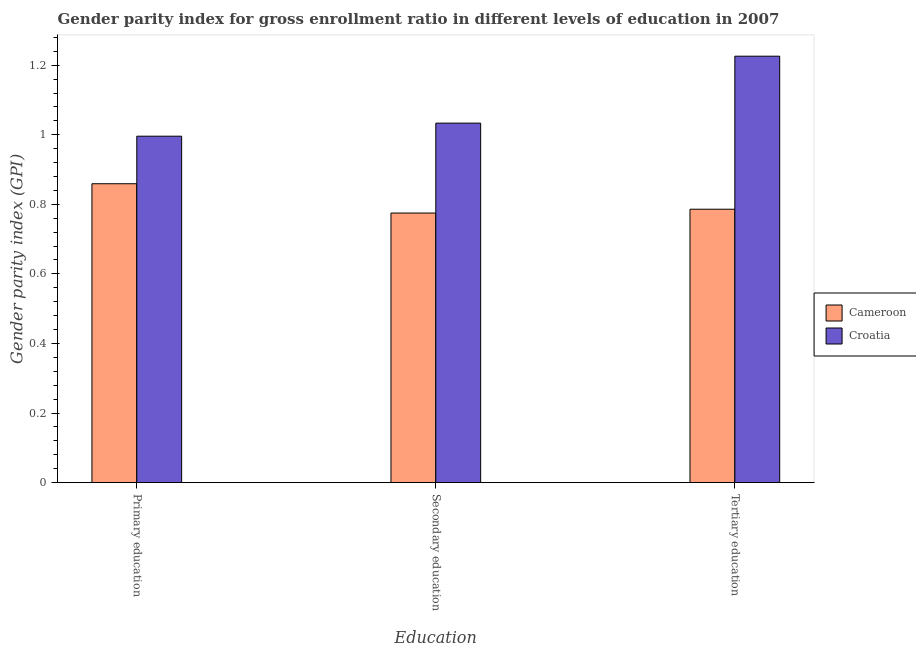How many groups of bars are there?
Provide a succinct answer. 3. Are the number of bars per tick equal to the number of legend labels?
Provide a short and direct response. Yes. What is the label of the 1st group of bars from the left?
Offer a terse response. Primary education. What is the gender parity index in secondary education in Cameroon?
Provide a succinct answer. 0.77. Across all countries, what is the maximum gender parity index in tertiary education?
Ensure brevity in your answer.  1.23. Across all countries, what is the minimum gender parity index in tertiary education?
Your response must be concise. 0.79. In which country was the gender parity index in primary education maximum?
Your answer should be compact. Croatia. In which country was the gender parity index in tertiary education minimum?
Your answer should be compact. Cameroon. What is the total gender parity index in primary education in the graph?
Your response must be concise. 1.86. What is the difference between the gender parity index in secondary education in Croatia and that in Cameroon?
Provide a succinct answer. 0.26. What is the difference between the gender parity index in tertiary education in Cameroon and the gender parity index in primary education in Croatia?
Your response must be concise. -0.21. What is the average gender parity index in secondary education per country?
Your answer should be very brief. 0.9. What is the difference between the gender parity index in primary education and gender parity index in secondary education in Cameroon?
Ensure brevity in your answer.  0.08. What is the ratio of the gender parity index in secondary education in Croatia to that in Cameroon?
Ensure brevity in your answer.  1.33. Is the gender parity index in primary education in Cameroon less than that in Croatia?
Your response must be concise. Yes. Is the difference between the gender parity index in primary education in Cameroon and Croatia greater than the difference between the gender parity index in secondary education in Cameroon and Croatia?
Your response must be concise. Yes. What is the difference between the highest and the second highest gender parity index in primary education?
Make the answer very short. 0.14. What is the difference between the highest and the lowest gender parity index in secondary education?
Your answer should be compact. 0.26. Is the sum of the gender parity index in secondary education in Croatia and Cameroon greater than the maximum gender parity index in tertiary education across all countries?
Your answer should be very brief. Yes. What does the 2nd bar from the left in Tertiary education represents?
Keep it short and to the point. Croatia. What does the 1st bar from the right in Secondary education represents?
Offer a terse response. Croatia. Is it the case that in every country, the sum of the gender parity index in primary education and gender parity index in secondary education is greater than the gender parity index in tertiary education?
Provide a short and direct response. Yes. Are all the bars in the graph horizontal?
Offer a very short reply. No. Are the values on the major ticks of Y-axis written in scientific E-notation?
Keep it short and to the point. No. Does the graph contain any zero values?
Keep it short and to the point. No. How many legend labels are there?
Offer a terse response. 2. What is the title of the graph?
Provide a short and direct response. Gender parity index for gross enrollment ratio in different levels of education in 2007. What is the label or title of the X-axis?
Provide a short and direct response. Education. What is the label or title of the Y-axis?
Ensure brevity in your answer.  Gender parity index (GPI). What is the Gender parity index (GPI) of Cameroon in Primary education?
Ensure brevity in your answer.  0.86. What is the Gender parity index (GPI) in Croatia in Primary education?
Ensure brevity in your answer.  1. What is the Gender parity index (GPI) of Cameroon in Secondary education?
Your answer should be very brief. 0.77. What is the Gender parity index (GPI) in Croatia in Secondary education?
Ensure brevity in your answer.  1.03. What is the Gender parity index (GPI) in Cameroon in Tertiary education?
Offer a terse response. 0.79. What is the Gender parity index (GPI) of Croatia in Tertiary education?
Keep it short and to the point. 1.23. Across all Education, what is the maximum Gender parity index (GPI) in Cameroon?
Your response must be concise. 0.86. Across all Education, what is the maximum Gender parity index (GPI) of Croatia?
Keep it short and to the point. 1.23. Across all Education, what is the minimum Gender parity index (GPI) of Cameroon?
Give a very brief answer. 0.77. Across all Education, what is the minimum Gender parity index (GPI) of Croatia?
Offer a very short reply. 1. What is the total Gender parity index (GPI) of Cameroon in the graph?
Make the answer very short. 2.42. What is the total Gender parity index (GPI) of Croatia in the graph?
Offer a very short reply. 3.26. What is the difference between the Gender parity index (GPI) of Cameroon in Primary education and that in Secondary education?
Make the answer very short. 0.08. What is the difference between the Gender parity index (GPI) of Croatia in Primary education and that in Secondary education?
Provide a short and direct response. -0.04. What is the difference between the Gender parity index (GPI) in Cameroon in Primary education and that in Tertiary education?
Your answer should be compact. 0.07. What is the difference between the Gender parity index (GPI) of Croatia in Primary education and that in Tertiary education?
Keep it short and to the point. -0.23. What is the difference between the Gender parity index (GPI) of Cameroon in Secondary education and that in Tertiary education?
Your answer should be compact. -0.01. What is the difference between the Gender parity index (GPI) in Croatia in Secondary education and that in Tertiary education?
Offer a terse response. -0.19. What is the difference between the Gender parity index (GPI) in Cameroon in Primary education and the Gender parity index (GPI) in Croatia in Secondary education?
Provide a succinct answer. -0.17. What is the difference between the Gender parity index (GPI) of Cameroon in Primary education and the Gender parity index (GPI) of Croatia in Tertiary education?
Your answer should be very brief. -0.37. What is the difference between the Gender parity index (GPI) in Cameroon in Secondary education and the Gender parity index (GPI) in Croatia in Tertiary education?
Your response must be concise. -0.45. What is the average Gender parity index (GPI) of Cameroon per Education?
Your response must be concise. 0.81. What is the average Gender parity index (GPI) of Croatia per Education?
Ensure brevity in your answer.  1.08. What is the difference between the Gender parity index (GPI) in Cameroon and Gender parity index (GPI) in Croatia in Primary education?
Your response must be concise. -0.14. What is the difference between the Gender parity index (GPI) of Cameroon and Gender parity index (GPI) of Croatia in Secondary education?
Provide a short and direct response. -0.26. What is the difference between the Gender parity index (GPI) of Cameroon and Gender parity index (GPI) of Croatia in Tertiary education?
Ensure brevity in your answer.  -0.44. What is the ratio of the Gender parity index (GPI) in Cameroon in Primary education to that in Secondary education?
Provide a short and direct response. 1.11. What is the ratio of the Gender parity index (GPI) of Croatia in Primary education to that in Secondary education?
Give a very brief answer. 0.96. What is the ratio of the Gender parity index (GPI) in Cameroon in Primary education to that in Tertiary education?
Your response must be concise. 1.09. What is the ratio of the Gender parity index (GPI) of Croatia in Primary education to that in Tertiary education?
Provide a short and direct response. 0.81. What is the ratio of the Gender parity index (GPI) of Croatia in Secondary education to that in Tertiary education?
Your response must be concise. 0.84. What is the difference between the highest and the second highest Gender parity index (GPI) in Cameroon?
Your answer should be compact. 0.07. What is the difference between the highest and the second highest Gender parity index (GPI) in Croatia?
Your answer should be very brief. 0.19. What is the difference between the highest and the lowest Gender parity index (GPI) of Cameroon?
Your response must be concise. 0.08. What is the difference between the highest and the lowest Gender parity index (GPI) in Croatia?
Keep it short and to the point. 0.23. 